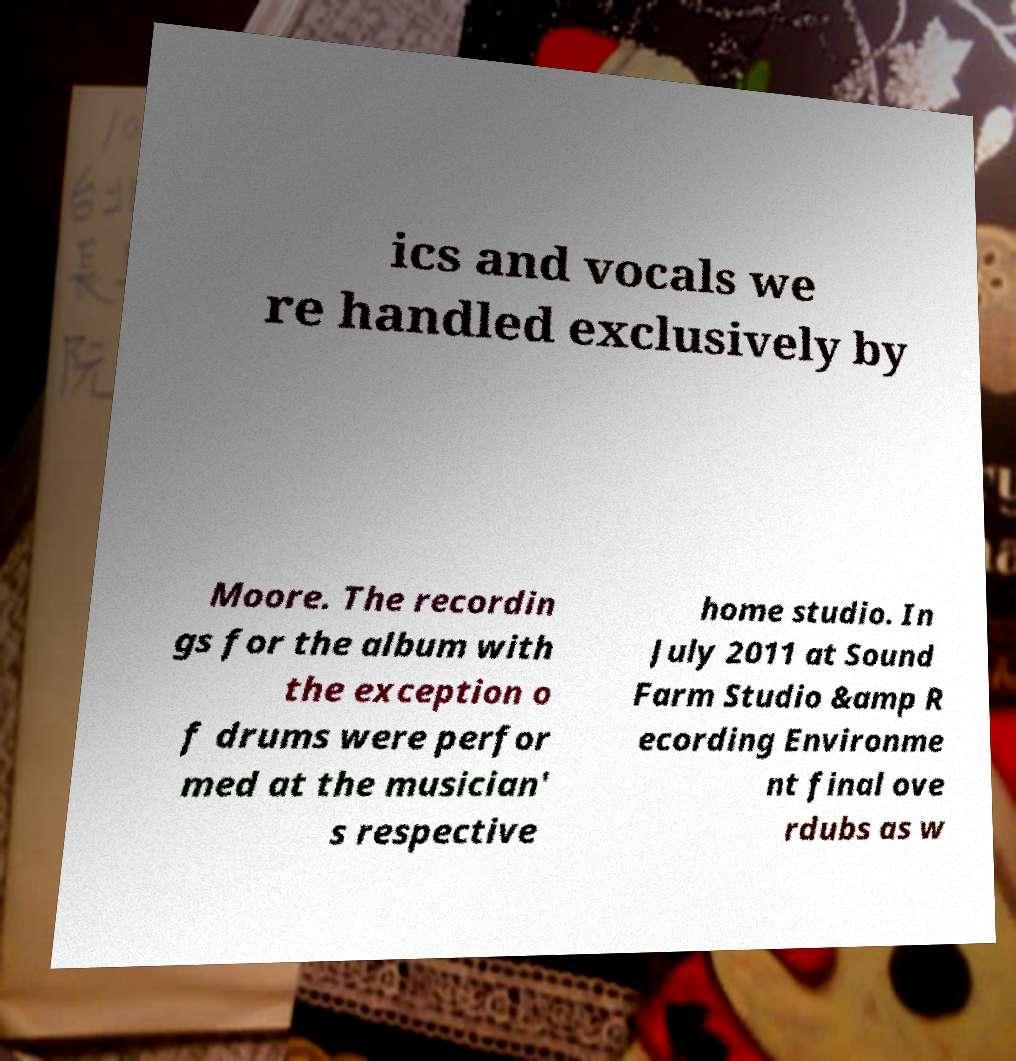I need the written content from this picture converted into text. Can you do that? ics and vocals we re handled exclusively by Moore. The recordin gs for the album with the exception o f drums were perfor med at the musician' s respective home studio. In July 2011 at Sound Farm Studio &amp R ecording Environme nt final ove rdubs as w 